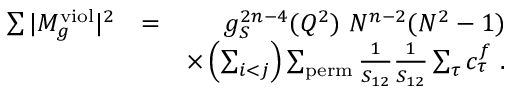<formula> <loc_0><loc_0><loc_500><loc_500>\begin{array} { r l r } { \sum | M _ { g } ^ { v i o l } | ^ { 2 } } & { = } & { g _ { S } ^ { 2 n - 4 } ( Q ^ { 2 } ) N ^ { n - 2 } ( N ^ { 2 } - 1 ) } \\ & { \times \left ( \sum _ { i < j } \right ) \sum _ { p e r m } \frac { 1 } { S _ { 1 2 } } \frac { 1 } { S _ { 1 2 } } \sum _ { \tau } c _ { \tau } ^ { f } . } \end{array}</formula> 